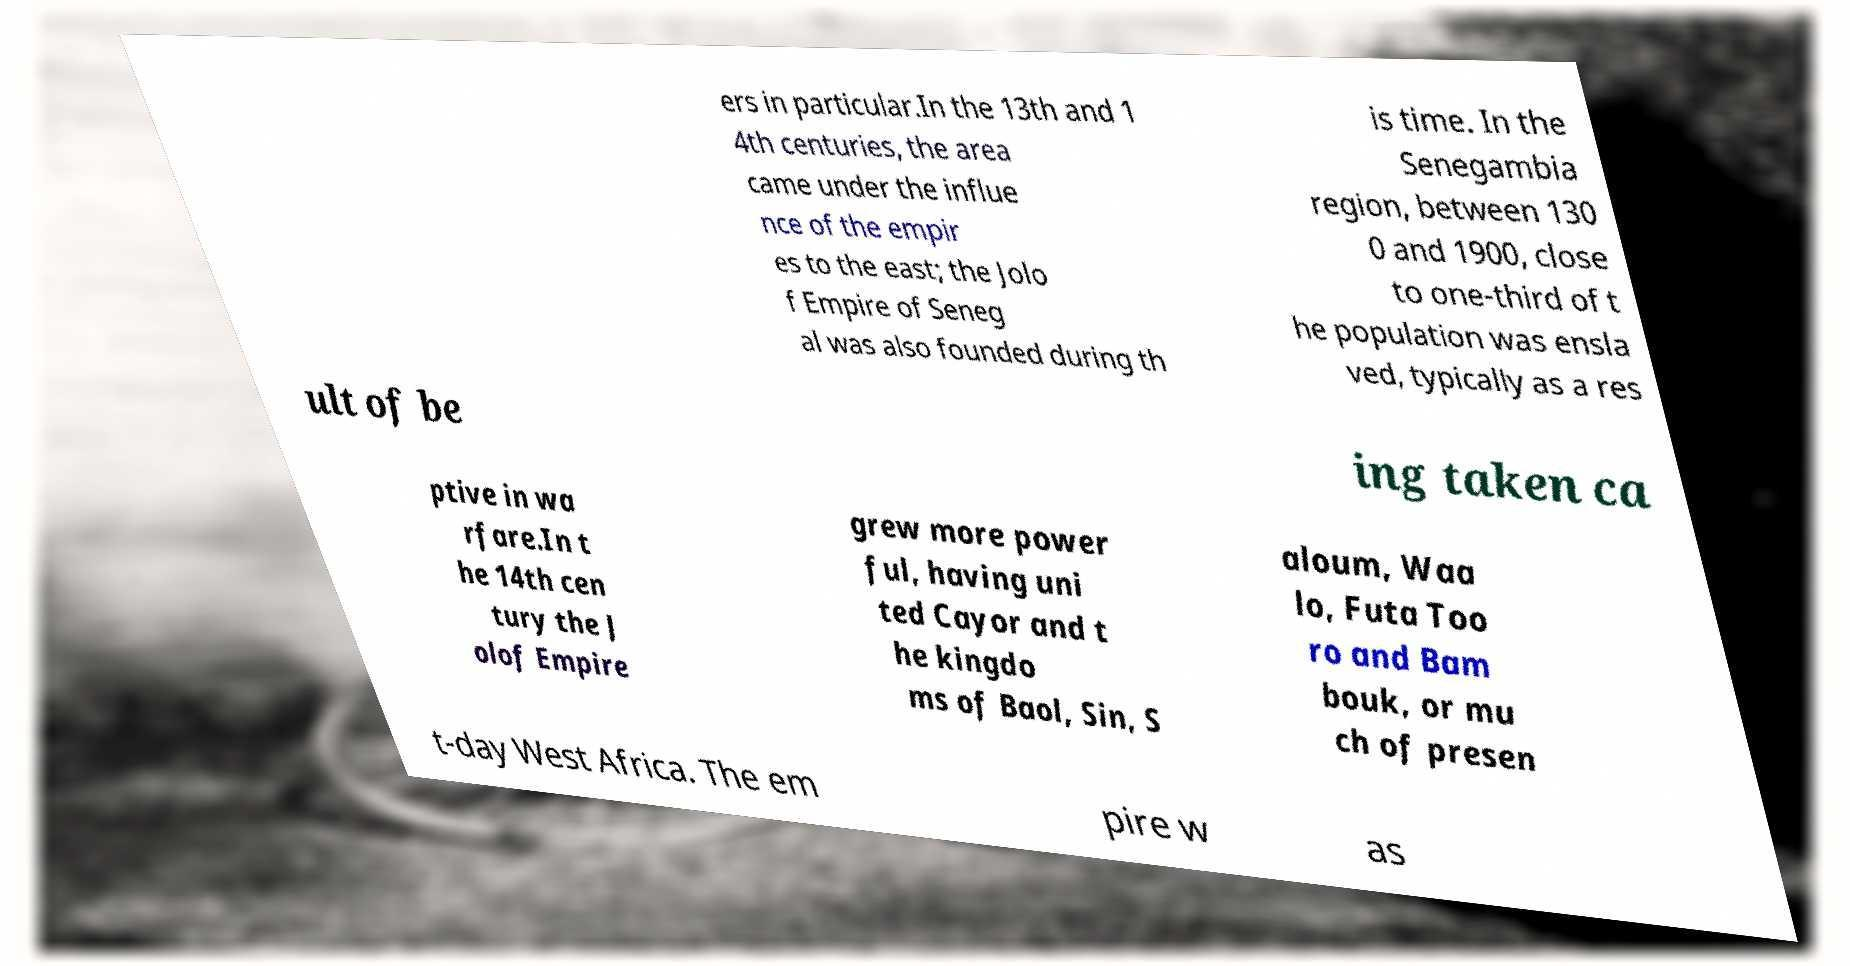Please identify and transcribe the text found in this image. ers in particular.In the 13th and 1 4th centuries, the area came under the influe nce of the empir es to the east; the Jolo f Empire of Seneg al was also founded during th is time. In the Senegambia region, between 130 0 and 1900, close to one-third of t he population was ensla ved, typically as a res ult of be ing taken ca ptive in wa rfare.In t he 14th cen tury the J olof Empire grew more power ful, having uni ted Cayor and t he kingdo ms of Baol, Sin, S aloum, Waa lo, Futa Too ro and Bam bouk, or mu ch of presen t-day West Africa. The em pire w as 